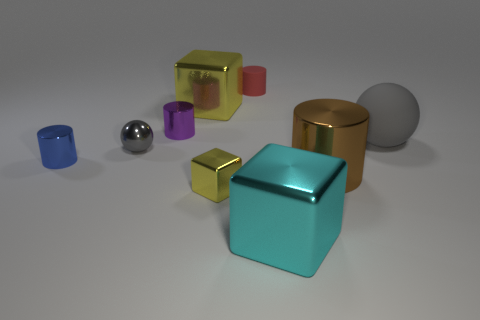Add 1 large yellow objects. How many objects exist? 10 Subtract all cylinders. How many objects are left? 5 Subtract 1 blue cylinders. How many objects are left? 8 Subtract all brown shiny cylinders. Subtract all gray rubber balls. How many objects are left? 7 Add 8 small red rubber cylinders. How many small red rubber cylinders are left? 9 Add 2 matte cylinders. How many matte cylinders exist? 3 